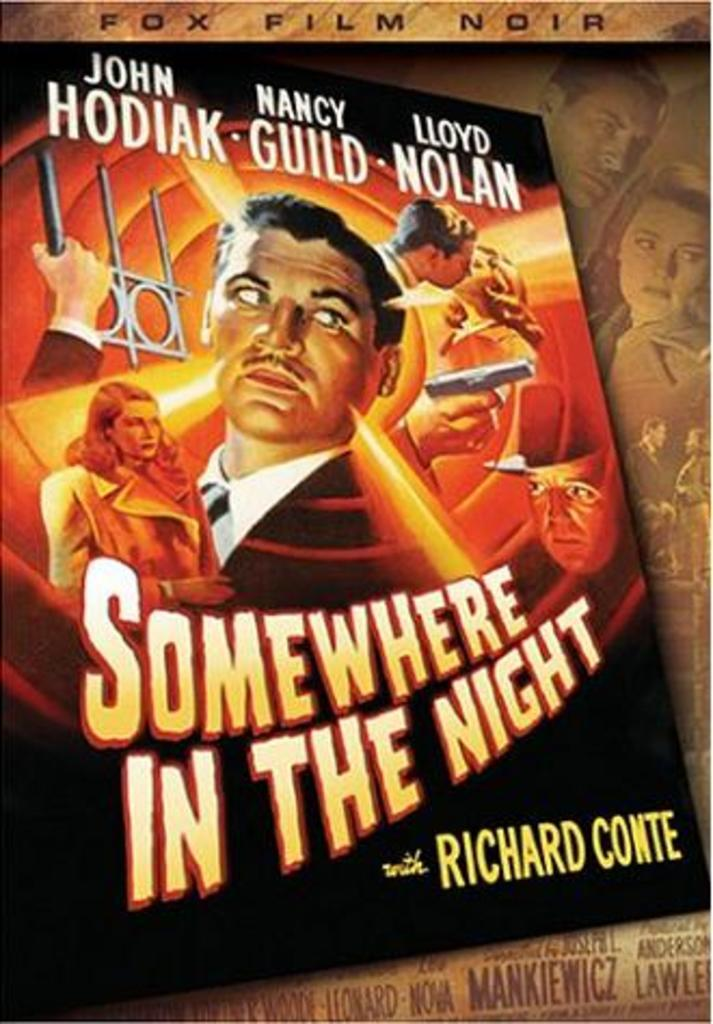<image>
Offer a succinct explanation of the picture presented. Somewhere in the Night has a man in a suit and a blonde woman on the cover. 